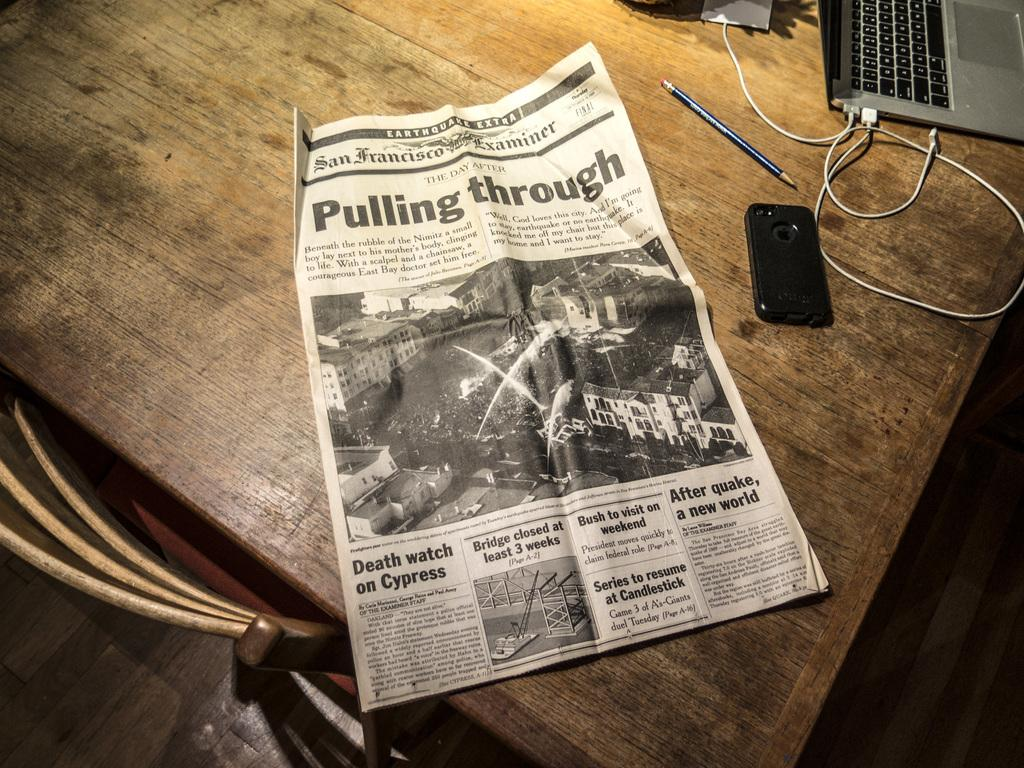<image>
Summarize the visual content of the image. A newspaper with the headline Pulling Through rests on a wooden table. 